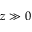<formula> <loc_0><loc_0><loc_500><loc_500>z \gg 0</formula> 